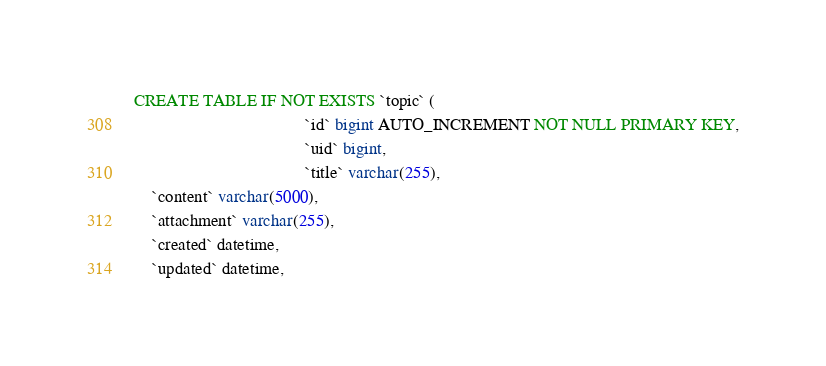Convert code to text. <code><loc_0><loc_0><loc_500><loc_500><_SQL_>CREATE TABLE IF NOT EXISTS `topic` (
                                       `id` bigint AUTO_INCREMENT NOT NULL PRIMARY KEY,
                                       `uid` bigint,
                                       `title` varchar(255),
    `content` varchar(5000),
    `attachment` varchar(255),
    `created` datetime,
    `updated` datetime,</code> 